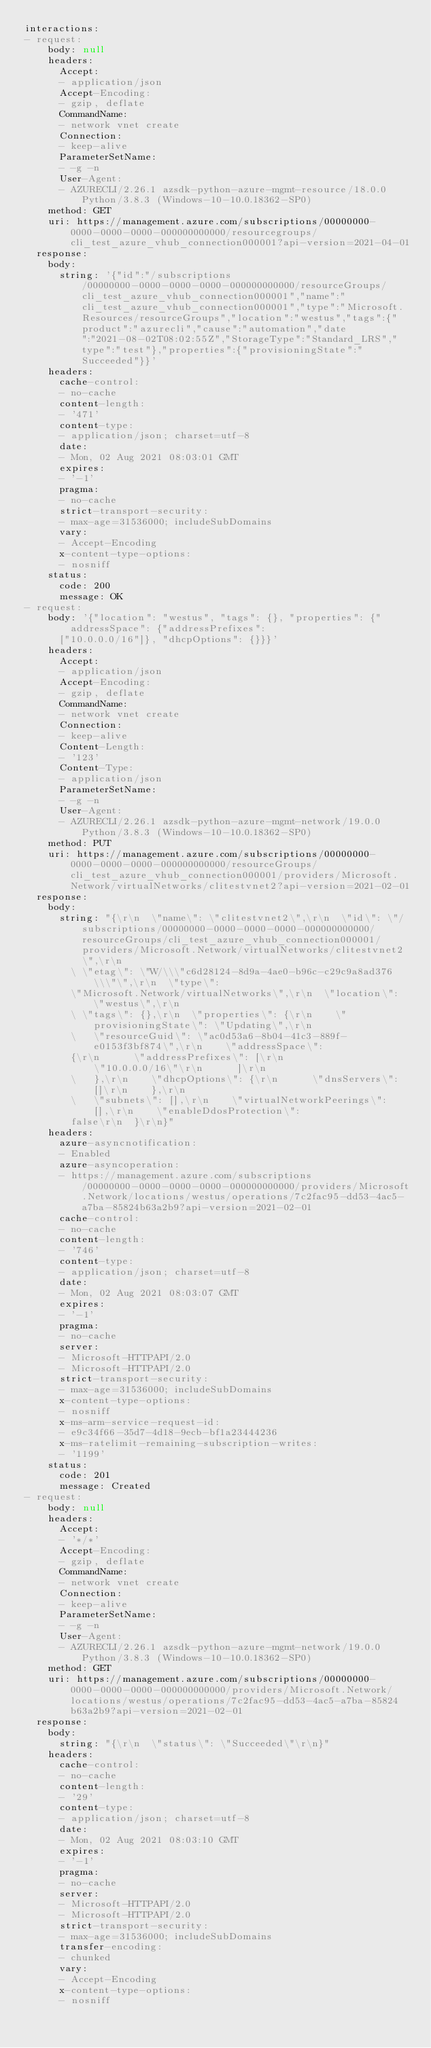Convert code to text. <code><loc_0><loc_0><loc_500><loc_500><_YAML_>interactions:
- request:
    body: null
    headers:
      Accept:
      - application/json
      Accept-Encoding:
      - gzip, deflate
      CommandName:
      - network vnet create
      Connection:
      - keep-alive
      ParameterSetName:
      - -g -n
      User-Agent:
      - AZURECLI/2.26.1 azsdk-python-azure-mgmt-resource/18.0.0 Python/3.8.3 (Windows-10-10.0.18362-SP0)
    method: GET
    uri: https://management.azure.com/subscriptions/00000000-0000-0000-0000-000000000000/resourcegroups/cli_test_azure_vhub_connection000001?api-version=2021-04-01
  response:
    body:
      string: '{"id":"/subscriptions/00000000-0000-0000-0000-000000000000/resourceGroups/cli_test_azure_vhub_connection000001","name":"cli_test_azure_vhub_connection000001","type":"Microsoft.Resources/resourceGroups","location":"westus","tags":{"product":"azurecli","cause":"automation","date":"2021-08-02T08:02:55Z","StorageType":"Standard_LRS","type":"test"},"properties":{"provisioningState":"Succeeded"}}'
    headers:
      cache-control:
      - no-cache
      content-length:
      - '471'
      content-type:
      - application/json; charset=utf-8
      date:
      - Mon, 02 Aug 2021 08:03:01 GMT
      expires:
      - '-1'
      pragma:
      - no-cache
      strict-transport-security:
      - max-age=31536000; includeSubDomains
      vary:
      - Accept-Encoding
      x-content-type-options:
      - nosniff
    status:
      code: 200
      message: OK
- request:
    body: '{"location": "westus", "tags": {}, "properties": {"addressSpace": {"addressPrefixes":
      ["10.0.0.0/16"]}, "dhcpOptions": {}}}'
    headers:
      Accept:
      - application/json
      Accept-Encoding:
      - gzip, deflate
      CommandName:
      - network vnet create
      Connection:
      - keep-alive
      Content-Length:
      - '123'
      Content-Type:
      - application/json
      ParameterSetName:
      - -g -n
      User-Agent:
      - AZURECLI/2.26.1 azsdk-python-azure-mgmt-network/19.0.0 Python/3.8.3 (Windows-10-10.0.18362-SP0)
    method: PUT
    uri: https://management.azure.com/subscriptions/00000000-0000-0000-0000-000000000000/resourceGroups/cli_test_azure_vhub_connection000001/providers/Microsoft.Network/virtualNetworks/clitestvnet2?api-version=2021-02-01
  response:
    body:
      string: "{\r\n  \"name\": \"clitestvnet2\",\r\n  \"id\": \"/subscriptions/00000000-0000-0000-0000-000000000000/resourceGroups/cli_test_azure_vhub_connection000001/providers/Microsoft.Network/virtualNetworks/clitestvnet2\",\r\n
        \ \"etag\": \"W/\\\"c6d28124-8d9a-4ae0-b96c-c29c9a8ad376\\\"\",\r\n  \"type\":
        \"Microsoft.Network/virtualNetworks\",\r\n  \"location\": \"westus\",\r\n
        \ \"tags\": {},\r\n  \"properties\": {\r\n    \"provisioningState\": \"Updating\",\r\n
        \   \"resourceGuid\": \"ac0d53a6-8b04-41c3-889f-e0153f3bf874\",\r\n    \"addressSpace\":
        {\r\n      \"addressPrefixes\": [\r\n        \"10.0.0.0/16\"\r\n      ]\r\n
        \   },\r\n    \"dhcpOptions\": {\r\n      \"dnsServers\": []\r\n    },\r\n
        \   \"subnets\": [],\r\n    \"virtualNetworkPeerings\": [],\r\n    \"enableDdosProtection\":
        false\r\n  }\r\n}"
    headers:
      azure-asyncnotification:
      - Enabled
      azure-asyncoperation:
      - https://management.azure.com/subscriptions/00000000-0000-0000-0000-000000000000/providers/Microsoft.Network/locations/westus/operations/7c2fac95-dd53-4ac5-a7ba-85824b63a2b9?api-version=2021-02-01
      cache-control:
      - no-cache
      content-length:
      - '746'
      content-type:
      - application/json; charset=utf-8
      date:
      - Mon, 02 Aug 2021 08:03:07 GMT
      expires:
      - '-1'
      pragma:
      - no-cache
      server:
      - Microsoft-HTTPAPI/2.0
      - Microsoft-HTTPAPI/2.0
      strict-transport-security:
      - max-age=31536000; includeSubDomains
      x-content-type-options:
      - nosniff
      x-ms-arm-service-request-id:
      - e9c34f66-35d7-4d18-9ecb-bf1a23444236
      x-ms-ratelimit-remaining-subscription-writes:
      - '1199'
    status:
      code: 201
      message: Created
- request:
    body: null
    headers:
      Accept:
      - '*/*'
      Accept-Encoding:
      - gzip, deflate
      CommandName:
      - network vnet create
      Connection:
      - keep-alive
      ParameterSetName:
      - -g -n
      User-Agent:
      - AZURECLI/2.26.1 azsdk-python-azure-mgmt-network/19.0.0 Python/3.8.3 (Windows-10-10.0.18362-SP0)
    method: GET
    uri: https://management.azure.com/subscriptions/00000000-0000-0000-0000-000000000000/providers/Microsoft.Network/locations/westus/operations/7c2fac95-dd53-4ac5-a7ba-85824b63a2b9?api-version=2021-02-01
  response:
    body:
      string: "{\r\n  \"status\": \"Succeeded\"\r\n}"
    headers:
      cache-control:
      - no-cache
      content-length:
      - '29'
      content-type:
      - application/json; charset=utf-8
      date:
      - Mon, 02 Aug 2021 08:03:10 GMT
      expires:
      - '-1'
      pragma:
      - no-cache
      server:
      - Microsoft-HTTPAPI/2.0
      - Microsoft-HTTPAPI/2.0
      strict-transport-security:
      - max-age=31536000; includeSubDomains
      transfer-encoding:
      - chunked
      vary:
      - Accept-Encoding
      x-content-type-options:
      - nosniff</code> 